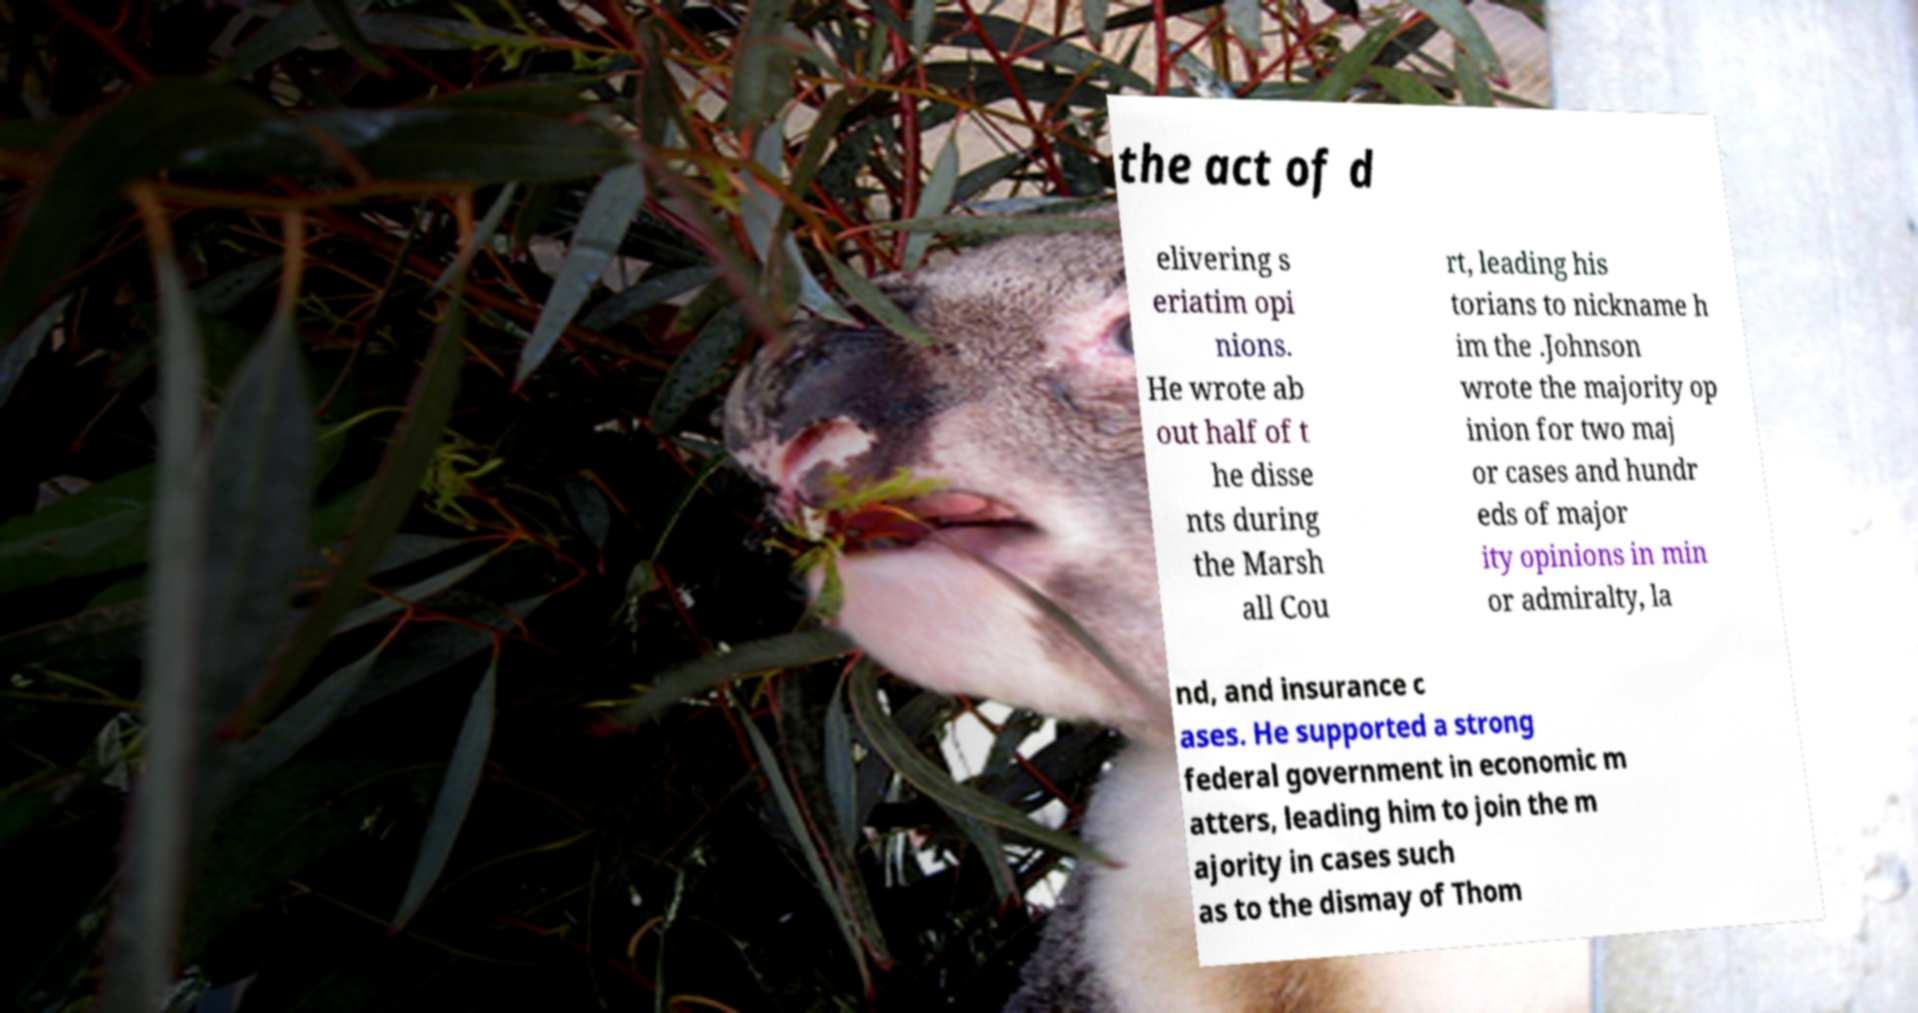For documentation purposes, I need the text within this image transcribed. Could you provide that? the act of d elivering s eriatim opi nions. He wrote ab out half of t he disse nts during the Marsh all Cou rt, leading his torians to nickname h im the .Johnson wrote the majority op inion for two maj or cases and hundr eds of major ity opinions in min or admiralty, la nd, and insurance c ases. He supported a strong federal government in economic m atters, leading him to join the m ajority in cases such as to the dismay of Thom 